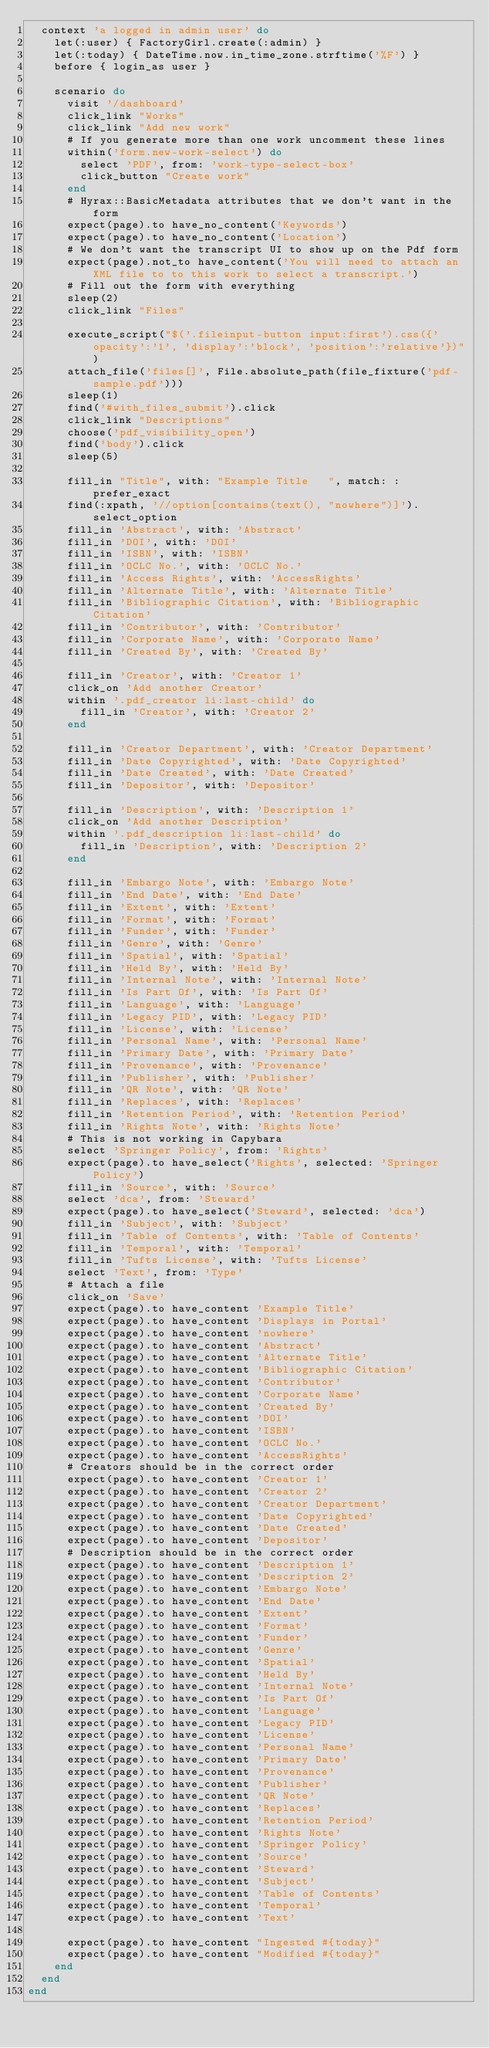Convert code to text. <code><loc_0><loc_0><loc_500><loc_500><_Ruby_>  context 'a logged in admin user' do
    let(:user) { FactoryGirl.create(:admin) }
    let(:today) { DateTime.now.in_time_zone.strftime('%F') }
    before { login_as user }

    scenario do
      visit '/dashboard'
      click_link "Works"
      click_link "Add new work"
      # If you generate more than one work uncomment these lines
      within('form.new-work-select') do
        select 'PDF', from: 'work-type-select-box'
        click_button "Create work"
      end
      # Hyrax::BasicMetadata attributes that we don't want in the form
      expect(page).to have_no_content('Keywords')
      expect(page).to have_no_content('Location')
      # We don't want the transcript UI to show up on the Pdf form
      expect(page).not_to have_content('You will need to attach an XML file to to this work to select a transcript.')
      # Fill out the form with everything
      sleep(2)
      click_link "Files"

      execute_script("$('.fileinput-button input:first').css({'opacity':'1', 'display':'block', 'position':'relative'})")
      attach_file('files[]', File.absolute_path(file_fixture('pdf-sample.pdf')))
      sleep(1)
      find('#with_files_submit').click
      click_link "Descriptions"
      choose('pdf_visibility_open')
      find('body').click
      sleep(5)

      fill_in "Title", with: "Example Title   ", match: :prefer_exact
      find(:xpath, '//option[contains(text(), "nowhere")]').select_option
      fill_in 'Abstract', with: 'Abstract'
      fill_in 'DOI', with: 'DOI'
      fill_in 'ISBN', with: 'ISBN'
      fill_in 'OCLC No.', with: 'OCLC No.'
      fill_in 'Access Rights', with: 'AccessRights'
      fill_in 'Alternate Title', with: 'Alternate Title'
      fill_in 'Bibliographic Citation', with: 'Bibliographic Citation'
      fill_in 'Contributor', with: 'Contributor'
      fill_in 'Corporate Name', with: 'Corporate Name'
      fill_in 'Created By', with: 'Created By'

      fill_in 'Creator', with: 'Creator 1'
      click_on 'Add another Creator'
      within '.pdf_creator li:last-child' do
        fill_in 'Creator', with: 'Creator 2'
      end

      fill_in 'Creator Department', with: 'Creator Department'
      fill_in 'Date Copyrighted', with: 'Date Copyrighted'
      fill_in 'Date Created', with: 'Date Created'
      fill_in 'Depositor', with: 'Depositor'

      fill_in 'Description', with: 'Description 1'
      click_on 'Add another Description'
      within '.pdf_description li:last-child' do
        fill_in 'Description', with: 'Description 2'
      end

      fill_in 'Embargo Note', with: 'Embargo Note'
      fill_in 'End Date', with: 'End Date'
      fill_in 'Extent', with: 'Extent'
      fill_in 'Format', with: 'Format'
      fill_in 'Funder', with: 'Funder'
      fill_in 'Genre', with: 'Genre'
      fill_in 'Spatial', with: 'Spatial'
      fill_in 'Held By', with: 'Held By'
      fill_in 'Internal Note', with: 'Internal Note'
      fill_in 'Is Part Of', with: 'Is Part Of'
      fill_in 'Language', with: 'Language'
      fill_in 'Legacy PID', with: 'Legacy PID'
      fill_in 'License', with: 'License'
      fill_in 'Personal Name', with: 'Personal Name'
      fill_in 'Primary Date', with: 'Primary Date'
      fill_in 'Provenance', with: 'Provenance'
      fill_in 'Publisher', with: 'Publisher'
      fill_in 'QR Note', with: 'QR Note'
      fill_in 'Replaces', with: 'Replaces'
      fill_in 'Retention Period', with: 'Retention Period'
      fill_in 'Rights Note', with: 'Rights Note'
      # This is not working in Capybara
      select 'Springer Policy', from: 'Rights'
      expect(page).to have_select('Rights', selected: 'Springer Policy')
      fill_in 'Source', with: 'Source'
      select 'dca', from: 'Steward'
      expect(page).to have_select('Steward', selected: 'dca')
      fill_in 'Subject', with: 'Subject'
      fill_in 'Table of Contents', with: 'Table of Contents'
      fill_in 'Temporal', with: 'Temporal'
      fill_in 'Tufts License', with: 'Tufts License'
      select 'Text', from: 'Type'
      # Attach a file
      click_on 'Save'
      expect(page).to have_content 'Example Title'
      expect(page).to have_content 'Displays in Portal'
      expect(page).to have_content 'nowhere'
      expect(page).to have_content 'Abstract'
      expect(page).to have_content 'Alternate Title'
      expect(page).to have_content 'Bibliographic Citation'
      expect(page).to have_content 'Contributor'
      expect(page).to have_content 'Corporate Name'
      expect(page).to have_content 'Created By'
      expect(page).to have_content 'DOI'
      expect(page).to have_content 'ISBN'
      expect(page).to have_content 'OCLC No.'
      expect(page).to have_content 'AccessRights'
      # Creators should be in the correct order
      expect(page).to have_content 'Creator 1'
      expect(page).to have_content 'Creator 2'
      expect(page).to have_content 'Creator Department'
      expect(page).to have_content 'Date Copyrighted'
      expect(page).to have_content 'Date Created'
      expect(page).to have_content 'Depositor'
      # Description should be in the correct order
      expect(page).to have_content 'Description 1'
      expect(page).to have_content 'Description 2'
      expect(page).to have_content 'Embargo Note'
      expect(page).to have_content 'End Date'
      expect(page).to have_content 'Extent'
      expect(page).to have_content 'Format'
      expect(page).to have_content 'Funder'
      expect(page).to have_content 'Genre'
      expect(page).to have_content 'Spatial'
      expect(page).to have_content 'Held By'
      expect(page).to have_content 'Internal Note'
      expect(page).to have_content 'Is Part Of'
      expect(page).to have_content 'Language'
      expect(page).to have_content 'Legacy PID'
      expect(page).to have_content 'License'
      expect(page).to have_content 'Personal Name'
      expect(page).to have_content 'Primary Date'
      expect(page).to have_content 'Provenance'
      expect(page).to have_content 'Publisher'
      expect(page).to have_content 'QR Note'
      expect(page).to have_content 'Replaces'
      expect(page).to have_content 'Retention Period'
      expect(page).to have_content 'Rights Note'
      expect(page).to have_content 'Springer Policy'
      expect(page).to have_content 'Source'
      expect(page).to have_content 'Steward'
      expect(page).to have_content 'Subject'
      expect(page).to have_content 'Table of Contents'
      expect(page).to have_content 'Temporal'
      expect(page).to have_content 'Text'

      expect(page).to have_content "Ingested #{today}"
      expect(page).to have_content "Modified #{today}"
    end
  end
end
</code> 